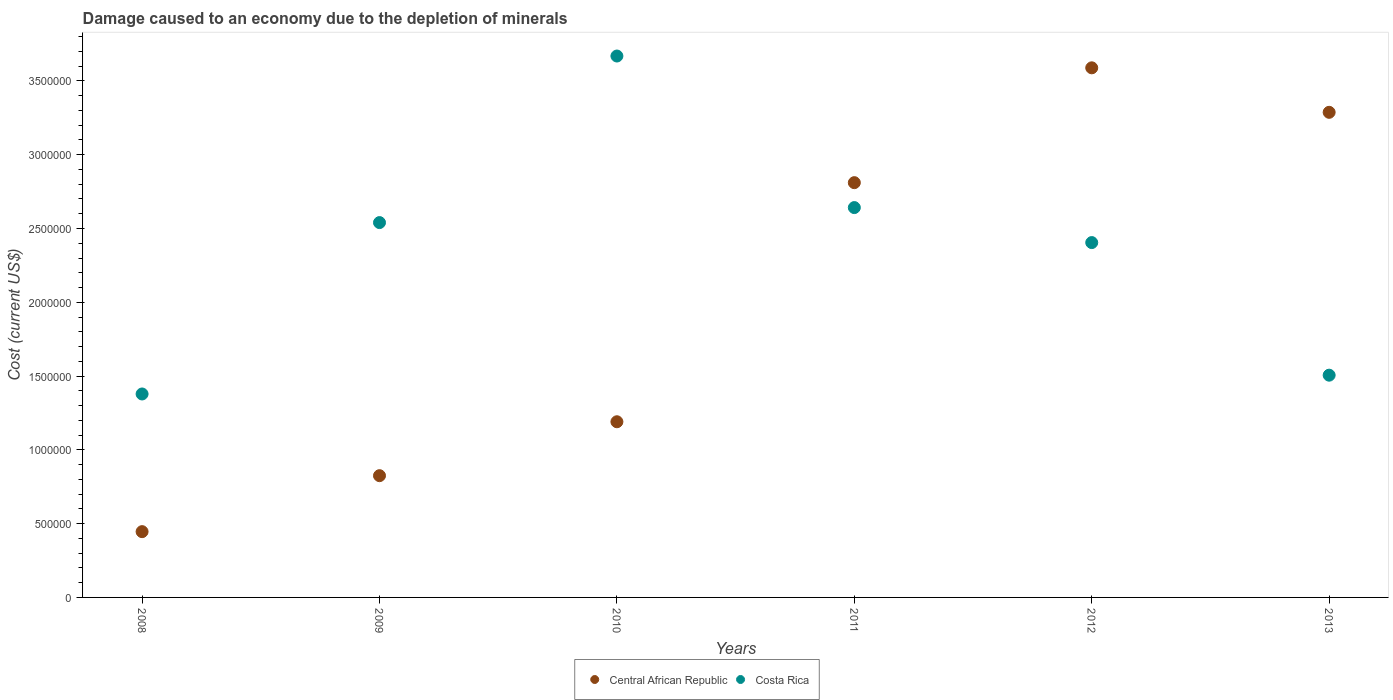What is the cost of damage caused due to the depletion of minerals in Costa Rica in 2008?
Your answer should be very brief. 1.38e+06. Across all years, what is the maximum cost of damage caused due to the depletion of minerals in Central African Republic?
Ensure brevity in your answer.  3.59e+06. Across all years, what is the minimum cost of damage caused due to the depletion of minerals in Costa Rica?
Keep it short and to the point. 1.38e+06. In which year was the cost of damage caused due to the depletion of minerals in Central African Republic minimum?
Give a very brief answer. 2008. What is the total cost of damage caused due to the depletion of minerals in Central African Republic in the graph?
Keep it short and to the point. 1.21e+07. What is the difference between the cost of damage caused due to the depletion of minerals in Costa Rica in 2008 and that in 2012?
Offer a terse response. -1.03e+06. What is the difference between the cost of damage caused due to the depletion of minerals in Central African Republic in 2008 and the cost of damage caused due to the depletion of minerals in Costa Rica in 2009?
Provide a short and direct response. -2.09e+06. What is the average cost of damage caused due to the depletion of minerals in Costa Rica per year?
Your response must be concise. 2.36e+06. In the year 2010, what is the difference between the cost of damage caused due to the depletion of minerals in Central African Republic and cost of damage caused due to the depletion of minerals in Costa Rica?
Keep it short and to the point. -2.48e+06. In how many years, is the cost of damage caused due to the depletion of minerals in Central African Republic greater than 1800000 US$?
Keep it short and to the point. 3. What is the ratio of the cost of damage caused due to the depletion of minerals in Costa Rica in 2010 to that in 2012?
Provide a succinct answer. 1.53. What is the difference between the highest and the second highest cost of damage caused due to the depletion of minerals in Costa Rica?
Give a very brief answer. 1.03e+06. What is the difference between the highest and the lowest cost of damage caused due to the depletion of minerals in Costa Rica?
Your response must be concise. 2.29e+06. Does the cost of damage caused due to the depletion of minerals in Central African Republic monotonically increase over the years?
Offer a terse response. No. Is the cost of damage caused due to the depletion of minerals in Central African Republic strictly less than the cost of damage caused due to the depletion of minerals in Costa Rica over the years?
Your response must be concise. No. How many dotlines are there?
Your answer should be very brief. 2. What is the difference between two consecutive major ticks on the Y-axis?
Ensure brevity in your answer.  5.00e+05. Where does the legend appear in the graph?
Your response must be concise. Bottom center. How many legend labels are there?
Your answer should be compact. 2. How are the legend labels stacked?
Provide a short and direct response. Horizontal. What is the title of the graph?
Offer a very short reply. Damage caused to an economy due to the depletion of minerals. What is the label or title of the X-axis?
Your answer should be very brief. Years. What is the label or title of the Y-axis?
Your response must be concise. Cost (current US$). What is the Cost (current US$) in Central African Republic in 2008?
Offer a very short reply. 4.46e+05. What is the Cost (current US$) in Costa Rica in 2008?
Your response must be concise. 1.38e+06. What is the Cost (current US$) of Central African Republic in 2009?
Give a very brief answer. 8.25e+05. What is the Cost (current US$) in Costa Rica in 2009?
Give a very brief answer. 2.54e+06. What is the Cost (current US$) of Central African Republic in 2010?
Make the answer very short. 1.19e+06. What is the Cost (current US$) in Costa Rica in 2010?
Ensure brevity in your answer.  3.67e+06. What is the Cost (current US$) in Central African Republic in 2011?
Keep it short and to the point. 2.81e+06. What is the Cost (current US$) in Costa Rica in 2011?
Make the answer very short. 2.64e+06. What is the Cost (current US$) of Central African Republic in 2012?
Your answer should be compact. 3.59e+06. What is the Cost (current US$) of Costa Rica in 2012?
Offer a terse response. 2.40e+06. What is the Cost (current US$) in Central African Republic in 2013?
Give a very brief answer. 3.29e+06. What is the Cost (current US$) of Costa Rica in 2013?
Your response must be concise. 1.51e+06. Across all years, what is the maximum Cost (current US$) in Central African Republic?
Provide a succinct answer. 3.59e+06. Across all years, what is the maximum Cost (current US$) in Costa Rica?
Your answer should be compact. 3.67e+06. Across all years, what is the minimum Cost (current US$) of Central African Republic?
Make the answer very short. 4.46e+05. Across all years, what is the minimum Cost (current US$) of Costa Rica?
Keep it short and to the point. 1.38e+06. What is the total Cost (current US$) of Central African Republic in the graph?
Ensure brevity in your answer.  1.21e+07. What is the total Cost (current US$) of Costa Rica in the graph?
Keep it short and to the point. 1.41e+07. What is the difference between the Cost (current US$) in Central African Republic in 2008 and that in 2009?
Provide a succinct answer. -3.79e+05. What is the difference between the Cost (current US$) in Costa Rica in 2008 and that in 2009?
Offer a terse response. -1.16e+06. What is the difference between the Cost (current US$) of Central African Republic in 2008 and that in 2010?
Your answer should be very brief. -7.45e+05. What is the difference between the Cost (current US$) of Costa Rica in 2008 and that in 2010?
Your answer should be compact. -2.29e+06. What is the difference between the Cost (current US$) of Central African Republic in 2008 and that in 2011?
Your answer should be very brief. -2.36e+06. What is the difference between the Cost (current US$) of Costa Rica in 2008 and that in 2011?
Offer a terse response. -1.26e+06. What is the difference between the Cost (current US$) in Central African Republic in 2008 and that in 2012?
Give a very brief answer. -3.14e+06. What is the difference between the Cost (current US$) in Costa Rica in 2008 and that in 2012?
Make the answer very short. -1.03e+06. What is the difference between the Cost (current US$) of Central African Republic in 2008 and that in 2013?
Your answer should be very brief. -2.84e+06. What is the difference between the Cost (current US$) in Costa Rica in 2008 and that in 2013?
Ensure brevity in your answer.  -1.27e+05. What is the difference between the Cost (current US$) in Central African Republic in 2009 and that in 2010?
Your answer should be very brief. -3.65e+05. What is the difference between the Cost (current US$) in Costa Rica in 2009 and that in 2010?
Give a very brief answer. -1.13e+06. What is the difference between the Cost (current US$) in Central African Republic in 2009 and that in 2011?
Keep it short and to the point. -1.99e+06. What is the difference between the Cost (current US$) of Costa Rica in 2009 and that in 2011?
Your answer should be compact. -1.02e+05. What is the difference between the Cost (current US$) in Central African Republic in 2009 and that in 2012?
Keep it short and to the point. -2.76e+06. What is the difference between the Cost (current US$) of Costa Rica in 2009 and that in 2012?
Offer a very short reply. 1.36e+05. What is the difference between the Cost (current US$) of Central African Republic in 2009 and that in 2013?
Ensure brevity in your answer.  -2.46e+06. What is the difference between the Cost (current US$) in Costa Rica in 2009 and that in 2013?
Provide a succinct answer. 1.03e+06. What is the difference between the Cost (current US$) in Central African Republic in 2010 and that in 2011?
Keep it short and to the point. -1.62e+06. What is the difference between the Cost (current US$) in Costa Rica in 2010 and that in 2011?
Make the answer very short. 1.03e+06. What is the difference between the Cost (current US$) of Central African Republic in 2010 and that in 2012?
Make the answer very short. -2.40e+06. What is the difference between the Cost (current US$) in Costa Rica in 2010 and that in 2012?
Your response must be concise. 1.26e+06. What is the difference between the Cost (current US$) of Central African Republic in 2010 and that in 2013?
Your response must be concise. -2.10e+06. What is the difference between the Cost (current US$) in Costa Rica in 2010 and that in 2013?
Provide a short and direct response. 2.16e+06. What is the difference between the Cost (current US$) of Central African Republic in 2011 and that in 2012?
Provide a short and direct response. -7.78e+05. What is the difference between the Cost (current US$) in Costa Rica in 2011 and that in 2012?
Make the answer very short. 2.37e+05. What is the difference between the Cost (current US$) of Central African Republic in 2011 and that in 2013?
Keep it short and to the point. -4.77e+05. What is the difference between the Cost (current US$) in Costa Rica in 2011 and that in 2013?
Your answer should be compact. 1.14e+06. What is the difference between the Cost (current US$) in Central African Republic in 2012 and that in 2013?
Make the answer very short. 3.01e+05. What is the difference between the Cost (current US$) in Costa Rica in 2012 and that in 2013?
Offer a very short reply. 8.99e+05. What is the difference between the Cost (current US$) of Central African Republic in 2008 and the Cost (current US$) of Costa Rica in 2009?
Give a very brief answer. -2.09e+06. What is the difference between the Cost (current US$) of Central African Republic in 2008 and the Cost (current US$) of Costa Rica in 2010?
Make the answer very short. -3.22e+06. What is the difference between the Cost (current US$) in Central African Republic in 2008 and the Cost (current US$) in Costa Rica in 2011?
Give a very brief answer. -2.20e+06. What is the difference between the Cost (current US$) of Central African Republic in 2008 and the Cost (current US$) of Costa Rica in 2012?
Ensure brevity in your answer.  -1.96e+06. What is the difference between the Cost (current US$) of Central African Republic in 2008 and the Cost (current US$) of Costa Rica in 2013?
Your answer should be very brief. -1.06e+06. What is the difference between the Cost (current US$) of Central African Republic in 2009 and the Cost (current US$) of Costa Rica in 2010?
Offer a terse response. -2.84e+06. What is the difference between the Cost (current US$) of Central African Republic in 2009 and the Cost (current US$) of Costa Rica in 2011?
Make the answer very short. -1.82e+06. What is the difference between the Cost (current US$) in Central African Republic in 2009 and the Cost (current US$) in Costa Rica in 2012?
Your answer should be very brief. -1.58e+06. What is the difference between the Cost (current US$) of Central African Republic in 2009 and the Cost (current US$) of Costa Rica in 2013?
Offer a very short reply. -6.81e+05. What is the difference between the Cost (current US$) in Central African Republic in 2010 and the Cost (current US$) in Costa Rica in 2011?
Ensure brevity in your answer.  -1.45e+06. What is the difference between the Cost (current US$) of Central African Republic in 2010 and the Cost (current US$) of Costa Rica in 2012?
Your response must be concise. -1.21e+06. What is the difference between the Cost (current US$) of Central African Republic in 2010 and the Cost (current US$) of Costa Rica in 2013?
Make the answer very short. -3.16e+05. What is the difference between the Cost (current US$) in Central African Republic in 2011 and the Cost (current US$) in Costa Rica in 2012?
Offer a very short reply. 4.06e+05. What is the difference between the Cost (current US$) of Central African Republic in 2011 and the Cost (current US$) of Costa Rica in 2013?
Provide a short and direct response. 1.30e+06. What is the difference between the Cost (current US$) of Central African Republic in 2012 and the Cost (current US$) of Costa Rica in 2013?
Your response must be concise. 2.08e+06. What is the average Cost (current US$) of Central African Republic per year?
Offer a terse response. 2.02e+06. What is the average Cost (current US$) of Costa Rica per year?
Provide a short and direct response. 2.36e+06. In the year 2008, what is the difference between the Cost (current US$) in Central African Republic and Cost (current US$) in Costa Rica?
Ensure brevity in your answer.  -9.33e+05. In the year 2009, what is the difference between the Cost (current US$) in Central African Republic and Cost (current US$) in Costa Rica?
Give a very brief answer. -1.72e+06. In the year 2010, what is the difference between the Cost (current US$) of Central African Republic and Cost (current US$) of Costa Rica?
Provide a short and direct response. -2.48e+06. In the year 2011, what is the difference between the Cost (current US$) of Central African Republic and Cost (current US$) of Costa Rica?
Your response must be concise. 1.69e+05. In the year 2012, what is the difference between the Cost (current US$) of Central African Republic and Cost (current US$) of Costa Rica?
Ensure brevity in your answer.  1.18e+06. In the year 2013, what is the difference between the Cost (current US$) in Central African Republic and Cost (current US$) in Costa Rica?
Keep it short and to the point. 1.78e+06. What is the ratio of the Cost (current US$) of Central African Republic in 2008 to that in 2009?
Provide a succinct answer. 0.54. What is the ratio of the Cost (current US$) of Costa Rica in 2008 to that in 2009?
Make the answer very short. 0.54. What is the ratio of the Cost (current US$) in Central African Republic in 2008 to that in 2010?
Your answer should be very brief. 0.37. What is the ratio of the Cost (current US$) in Costa Rica in 2008 to that in 2010?
Give a very brief answer. 0.38. What is the ratio of the Cost (current US$) of Central African Republic in 2008 to that in 2011?
Offer a very short reply. 0.16. What is the ratio of the Cost (current US$) in Costa Rica in 2008 to that in 2011?
Make the answer very short. 0.52. What is the ratio of the Cost (current US$) in Central African Republic in 2008 to that in 2012?
Give a very brief answer. 0.12. What is the ratio of the Cost (current US$) of Costa Rica in 2008 to that in 2012?
Ensure brevity in your answer.  0.57. What is the ratio of the Cost (current US$) in Central African Republic in 2008 to that in 2013?
Your answer should be compact. 0.14. What is the ratio of the Cost (current US$) in Costa Rica in 2008 to that in 2013?
Ensure brevity in your answer.  0.92. What is the ratio of the Cost (current US$) of Central African Republic in 2009 to that in 2010?
Your response must be concise. 0.69. What is the ratio of the Cost (current US$) in Costa Rica in 2009 to that in 2010?
Ensure brevity in your answer.  0.69. What is the ratio of the Cost (current US$) of Central African Republic in 2009 to that in 2011?
Your answer should be very brief. 0.29. What is the ratio of the Cost (current US$) in Costa Rica in 2009 to that in 2011?
Your answer should be compact. 0.96. What is the ratio of the Cost (current US$) in Central African Republic in 2009 to that in 2012?
Offer a very short reply. 0.23. What is the ratio of the Cost (current US$) in Costa Rica in 2009 to that in 2012?
Your answer should be very brief. 1.06. What is the ratio of the Cost (current US$) in Central African Republic in 2009 to that in 2013?
Provide a short and direct response. 0.25. What is the ratio of the Cost (current US$) of Costa Rica in 2009 to that in 2013?
Your answer should be compact. 1.69. What is the ratio of the Cost (current US$) in Central African Republic in 2010 to that in 2011?
Provide a short and direct response. 0.42. What is the ratio of the Cost (current US$) in Costa Rica in 2010 to that in 2011?
Give a very brief answer. 1.39. What is the ratio of the Cost (current US$) in Central African Republic in 2010 to that in 2012?
Keep it short and to the point. 0.33. What is the ratio of the Cost (current US$) in Costa Rica in 2010 to that in 2012?
Offer a very short reply. 1.53. What is the ratio of the Cost (current US$) of Central African Republic in 2010 to that in 2013?
Keep it short and to the point. 0.36. What is the ratio of the Cost (current US$) of Costa Rica in 2010 to that in 2013?
Your answer should be very brief. 2.44. What is the ratio of the Cost (current US$) in Central African Republic in 2011 to that in 2012?
Offer a very short reply. 0.78. What is the ratio of the Cost (current US$) in Costa Rica in 2011 to that in 2012?
Keep it short and to the point. 1.1. What is the ratio of the Cost (current US$) of Central African Republic in 2011 to that in 2013?
Ensure brevity in your answer.  0.85. What is the ratio of the Cost (current US$) of Costa Rica in 2011 to that in 2013?
Offer a very short reply. 1.75. What is the ratio of the Cost (current US$) in Central African Republic in 2012 to that in 2013?
Your answer should be very brief. 1.09. What is the ratio of the Cost (current US$) of Costa Rica in 2012 to that in 2013?
Give a very brief answer. 1.6. What is the difference between the highest and the second highest Cost (current US$) in Central African Republic?
Keep it short and to the point. 3.01e+05. What is the difference between the highest and the second highest Cost (current US$) of Costa Rica?
Your response must be concise. 1.03e+06. What is the difference between the highest and the lowest Cost (current US$) of Central African Republic?
Offer a very short reply. 3.14e+06. What is the difference between the highest and the lowest Cost (current US$) of Costa Rica?
Offer a very short reply. 2.29e+06. 